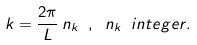Convert formula to latex. <formula><loc_0><loc_0><loc_500><loc_500>k = \frac { 2 \pi } { L } \, n _ { k } \ , \ n _ { k } \ i n t e g e r .</formula> 